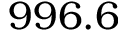<formula> <loc_0><loc_0><loc_500><loc_500>9 9 6 . 6</formula> 